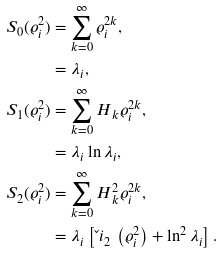Convert formula to latex. <formula><loc_0><loc_0><loc_500><loc_500>S _ { 0 } ( \varrho _ { i } ^ { 2 } ) & = \sum _ { k = 0 } ^ { \infty } \varrho _ { i } ^ { 2 k } , \\ & = \lambda _ { i } , \\ S _ { 1 } ( \varrho _ { i } ^ { 2 } ) & = \sum _ { k = 0 } ^ { \infty } { H } _ { \, k } \varrho _ { i } ^ { 2 k } , \\ & = \lambda _ { i } \ln \lambda _ { i } , \\ S _ { 2 } ( \varrho _ { i } ^ { 2 } ) & = \sum _ { k = 0 } ^ { \infty } { H } _ { \, k } ^ { 2 } \varrho _ { i } ^ { 2 k } , \\ & = \lambda _ { i } \left [ \L i _ { 2 } \, \left ( \varrho _ { i } ^ { 2 } \right ) + \ln ^ { 2 } \lambda _ { i } \right ] .</formula> 